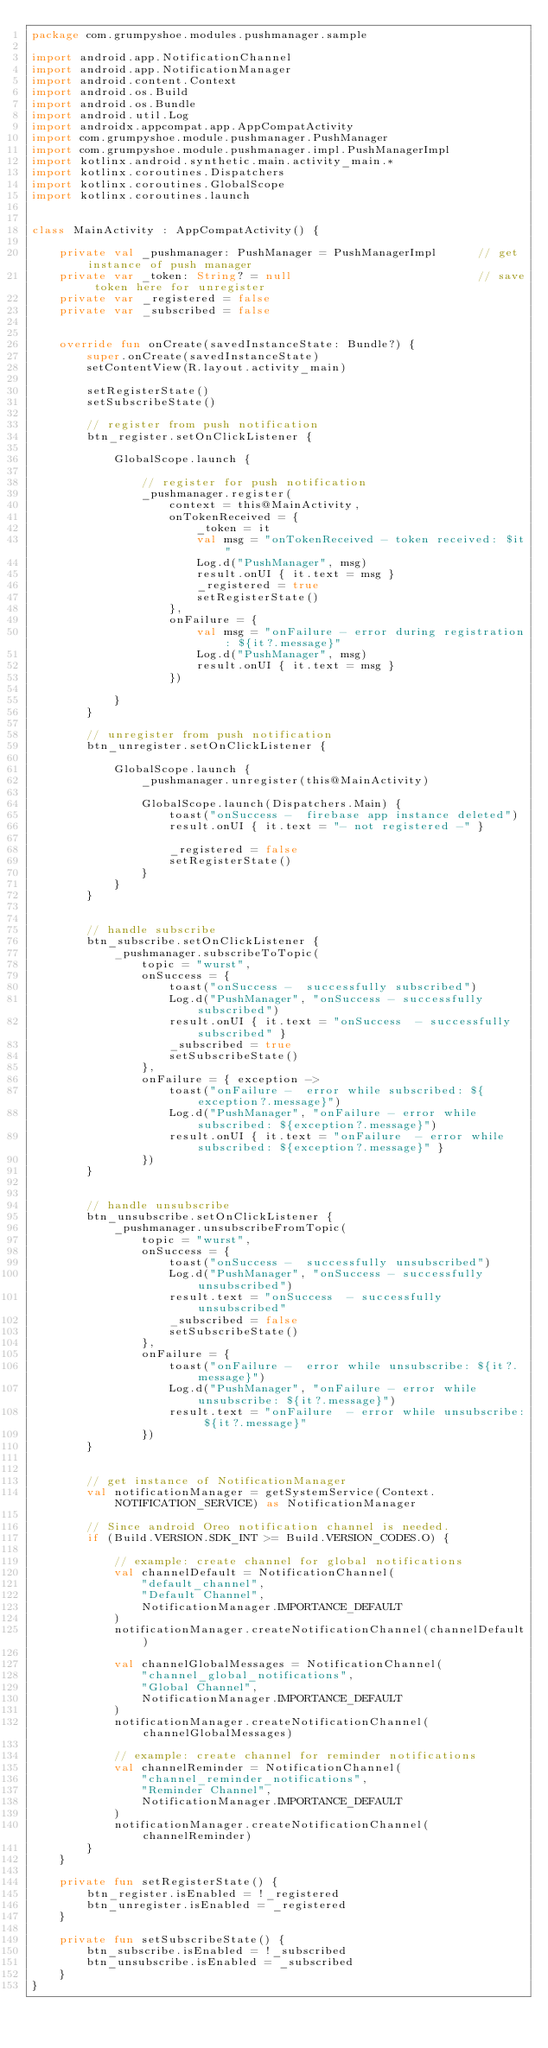<code> <loc_0><loc_0><loc_500><loc_500><_Kotlin_>package com.grumpyshoe.modules.pushmanager.sample

import android.app.NotificationChannel
import android.app.NotificationManager
import android.content.Context
import android.os.Build
import android.os.Bundle
import android.util.Log
import androidx.appcompat.app.AppCompatActivity
import com.grumpyshoe.module.pushmanager.PushManager
import com.grumpyshoe.module.pushmanager.impl.PushManagerImpl
import kotlinx.android.synthetic.main.activity_main.*
import kotlinx.coroutines.Dispatchers
import kotlinx.coroutines.GlobalScope
import kotlinx.coroutines.launch


class MainActivity : AppCompatActivity() {

    private val _pushmanager: PushManager = PushManagerImpl      // get instance of push manager
    private var _token: String? = null                           // save token here for unregister
    private var _registered = false
    private var _subscribed = false


    override fun onCreate(savedInstanceState: Bundle?) {
        super.onCreate(savedInstanceState)
        setContentView(R.layout.activity_main)

        setRegisterState()
        setSubscribeState()

        // register from push notification
        btn_register.setOnClickListener {

            GlobalScope.launch {

                // register for push notification
                _pushmanager.register(
                    context = this@MainActivity,
                    onTokenReceived = {
                        _token = it
                        val msg = "onTokenReceived - token received: $it"
                        Log.d("PushManager", msg)
                        result.onUI { it.text = msg }
                        _registered = true
                        setRegisterState()
                    },
                    onFailure = {
                        val msg = "onFailure - error during registration: ${it?.message}"
                        Log.d("PushManager", msg)
                        result.onUI { it.text = msg }
                    })

            }
        }

        // unregister from push notification
        btn_unregister.setOnClickListener {

            GlobalScope.launch {
                _pushmanager.unregister(this@MainActivity)

                GlobalScope.launch(Dispatchers.Main) {
                    toast("onSuccess -  firebase app instance deleted")
                    result.onUI { it.text = "- not registered -" }

                    _registered = false
                    setRegisterState()
                }
            }
        }


        // handle subscribe
        btn_subscribe.setOnClickListener {
            _pushmanager.subscribeToTopic(
                topic = "wurst",
                onSuccess = {
                    toast("onSuccess -  successfully subscribed")
                    Log.d("PushManager", "onSuccess - successfully subscribed")
                    result.onUI { it.text = "onSuccess  - successfully subscribed" }
                    _subscribed = true
                    setSubscribeState()
                },
                onFailure = { exception ->
                    toast("onFailure -  error while subscribed: ${exception?.message}")
                    Log.d("PushManager", "onFailure - error while subscribed: ${exception?.message}")
                    result.onUI { it.text = "onFailure  - error while subscribed: ${exception?.message}" }
                })
        }


        // handle unsubscribe
        btn_unsubscribe.setOnClickListener {
            _pushmanager.unsubscribeFromTopic(
                topic = "wurst",
                onSuccess = {
                    toast("onSuccess -  successfully unsubscribed")
                    Log.d("PushManager", "onSuccess - successfully unsubscribed")
                    result.text = "onSuccess  - successfully unsubscribed"
                    _subscribed = false
                    setSubscribeState()
                },
                onFailure = {
                    toast("onFailure -  error while unsubscribe: ${it?.message}")
                    Log.d("PushManager", "onFailure - error while unsubscribe: ${it?.message}")
                    result.text = "onFailure  - error while unsubscribe: ${it?.message}"
                })
        }


        // get instance of NotificationManager
        val notificationManager = getSystemService(Context.NOTIFICATION_SERVICE) as NotificationManager

        // Since android Oreo notification channel is needed.
        if (Build.VERSION.SDK_INT >= Build.VERSION_CODES.O) {

            // example: create channel for global notifications
            val channelDefault = NotificationChannel(
                "default_channel",
                "Default Channel",
                NotificationManager.IMPORTANCE_DEFAULT
            )
            notificationManager.createNotificationChannel(channelDefault)

            val channelGlobalMessages = NotificationChannel(
                "channel_global_notifications",
                "Global Channel",
                NotificationManager.IMPORTANCE_DEFAULT
            )
            notificationManager.createNotificationChannel(channelGlobalMessages)

            // example: create channel for reminder notifications
            val channelReminder = NotificationChannel(
                "channel_reminder_notifications",
                "Reminder Channel",
                NotificationManager.IMPORTANCE_DEFAULT
            )
            notificationManager.createNotificationChannel(channelReminder)
        }
    }

    private fun setRegisterState() {
        btn_register.isEnabled = !_registered
        btn_unregister.isEnabled = _registered
    }

    private fun setSubscribeState() {
        btn_subscribe.isEnabled = !_subscribed
        btn_unsubscribe.isEnabled = _subscribed
    }
}
</code> 